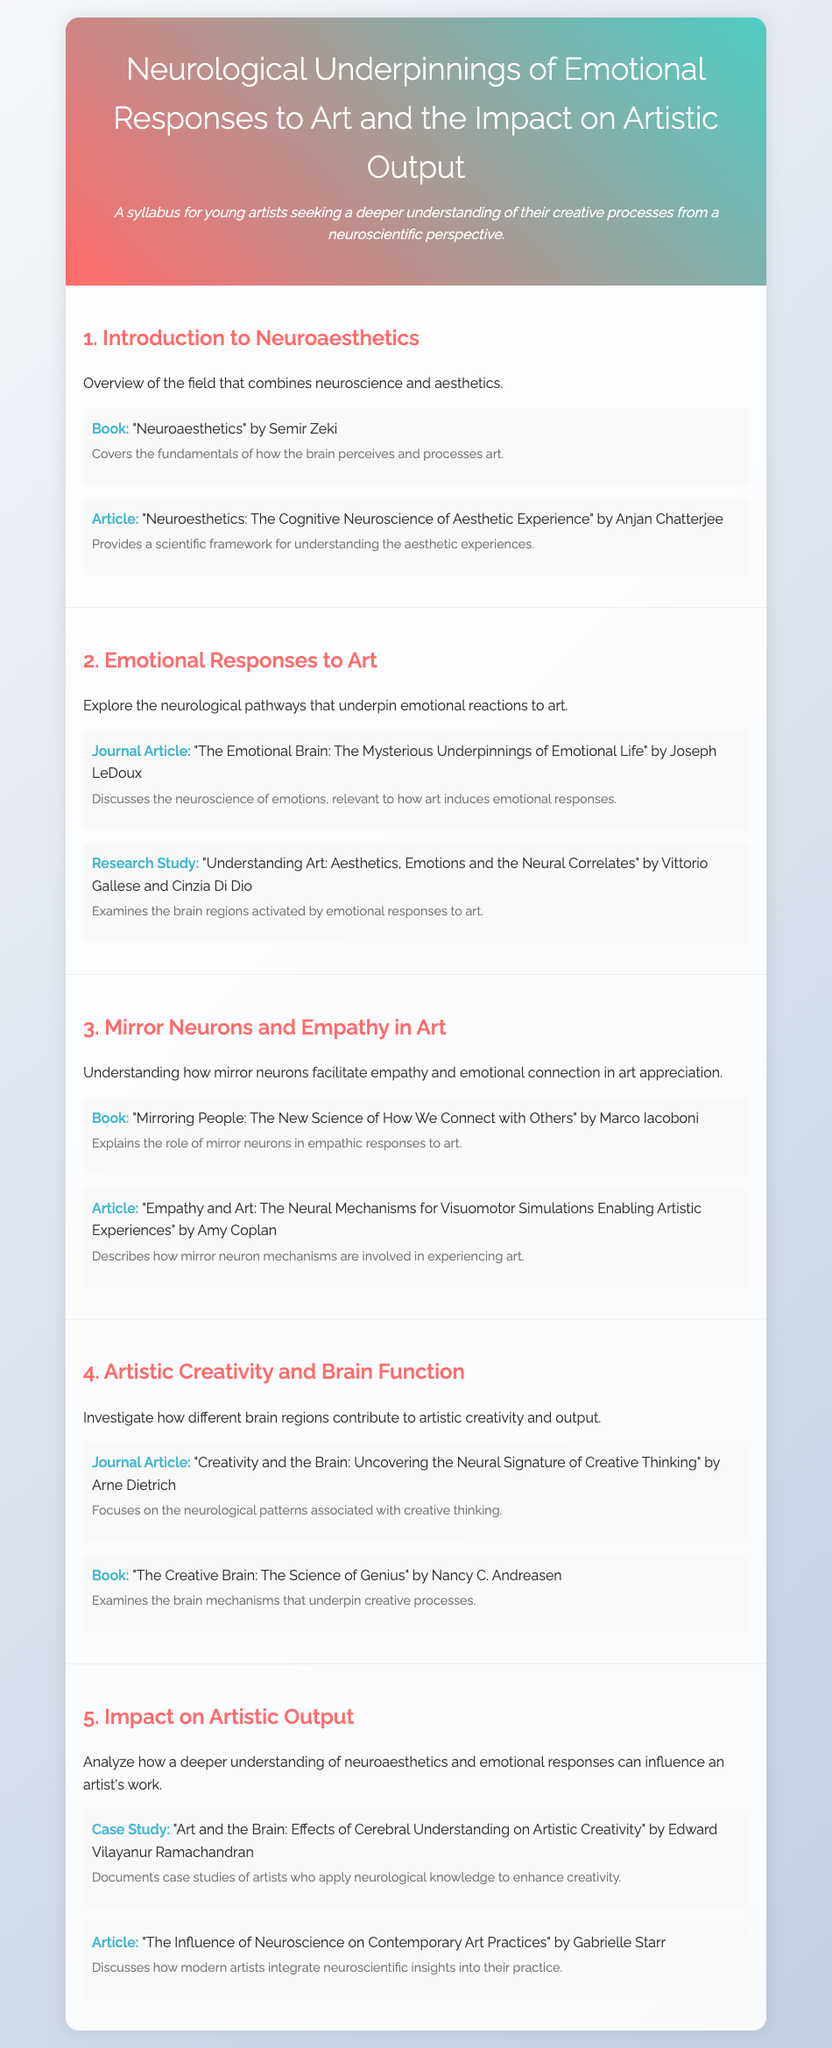what is the title of the syllabus? The title of the syllabus, as presented in the document, is at the top of the header section.
Answer: Neurological Underpinnings of Emotional Responses to Art and the Impact on Artistic Output who is the author of the book "Neuroaesthetics"? The author of the book "Neuroaesthetics" is mentioned in the first section of the document.
Answer: Semir Zeki what does the second section focus on? The second section provides an overview of the topic covered, specifically detailing the main theme of emotional responses to art.
Answer: Emotional Responses to Art which author discusses emotional life in a journal article? The author of the journal article that discusses emotional life is cited in the second section.
Answer: Joseph LeDoux what are mirror neurons associated with according to the third section? The role of mirror neurons is explained in the third section, indicating their importance in certain experiences.
Answer: Empathy and emotional connection in art how many materials are listed in the fourth section? The number of materials provided can be found by counting the items listed in that section.
Answer: Two who wrote "The Creative Brain: The Science of Genius"? This information is listed in the fourth section along with related details.
Answer: Nancy C. Andreasen what is the focus of the fifth section? The fifth section outlines the main idea discussed and can be found within its introductory statement.
Answer: Impact on Artistic Output 